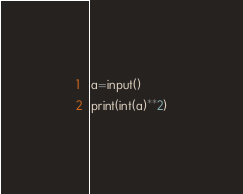<code> <loc_0><loc_0><loc_500><loc_500><_Python_>a=input()
print(int(a)**2)</code> 